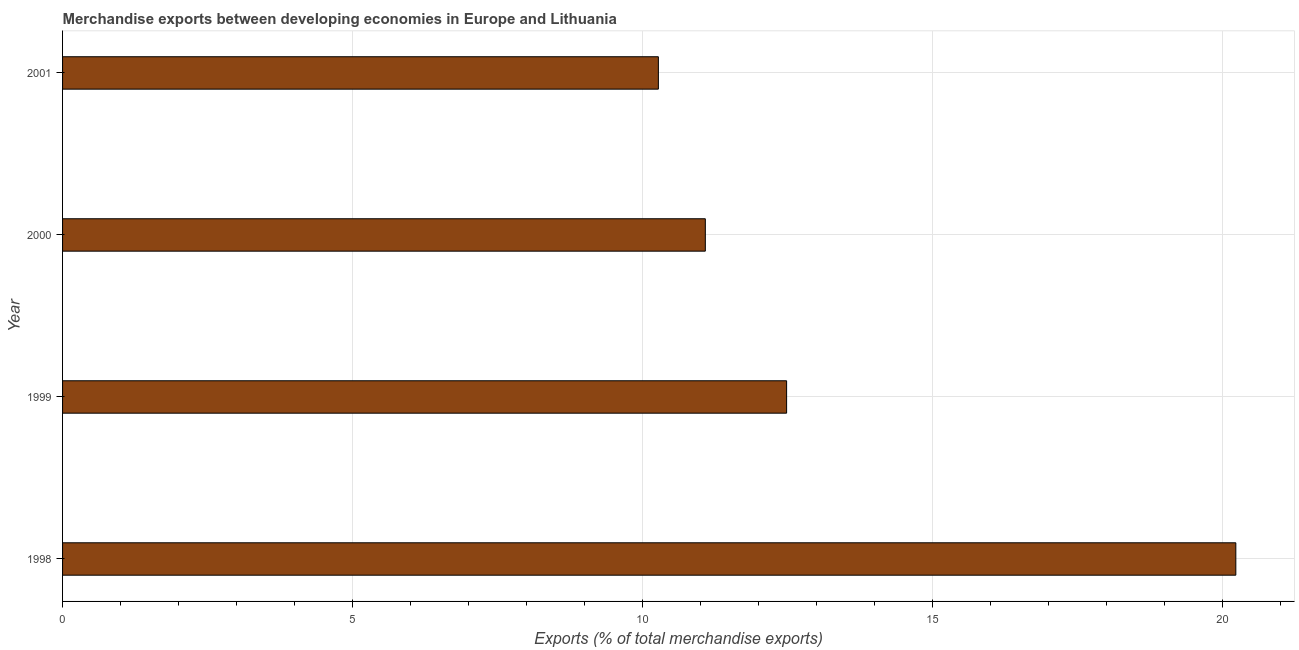Does the graph contain any zero values?
Your response must be concise. No. What is the title of the graph?
Ensure brevity in your answer.  Merchandise exports between developing economies in Europe and Lithuania. What is the label or title of the X-axis?
Give a very brief answer. Exports (% of total merchandise exports). What is the merchandise exports in 1999?
Offer a terse response. 12.49. Across all years, what is the maximum merchandise exports?
Provide a short and direct response. 20.23. Across all years, what is the minimum merchandise exports?
Your answer should be very brief. 10.28. In which year was the merchandise exports maximum?
Your response must be concise. 1998. In which year was the merchandise exports minimum?
Your answer should be very brief. 2001. What is the sum of the merchandise exports?
Give a very brief answer. 54.08. What is the difference between the merchandise exports in 1998 and 1999?
Provide a short and direct response. 7.75. What is the average merchandise exports per year?
Your answer should be very brief. 13.52. What is the median merchandise exports?
Provide a succinct answer. 11.79. Do a majority of the years between 1999 and 1998 (inclusive) have merchandise exports greater than 20 %?
Provide a succinct answer. No. What is the ratio of the merchandise exports in 1999 to that in 2001?
Offer a terse response. 1.22. Is the merchandise exports in 1998 less than that in 1999?
Your answer should be compact. No. What is the difference between the highest and the second highest merchandise exports?
Your answer should be very brief. 7.75. What is the difference between the highest and the lowest merchandise exports?
Give a very brief answer. 9.96. In how many years, is the merchandise exports greater than the average merchandise exports taken over all years?
Offer a very short reply. 1. Are all the bars in the graph horizontal?
Keep it short and to the point. Yes. What is the difference between two consecutive major ticks on the X-axis?
Your answer should be very brief. 5. What is the Exports (% of total merchandise exports) of 1998?
Make the answer very short. 20.23. What is the Exports (% of total merchandise exports) in 1999?
Offer a terse response. 12.49. What is the Exports (% of total merchandise exports) of 2000?
Provide a short and direct response. 11.09. What is the Exports (% of total merchandise exports) in 2001?
Your answer should be very brief. 10.28. What is the difference between the Exports (% of total merchandise exports) in 1998 and 1999?
Ensure brevity in your answer.  7.75. What is the difference between the Exports (% of total merchandise exports) in 1998 and 2000?
Provide a short and direct response. 9.15. What is the difference between the Exports (% of total merchandise exports) in 1998 and 2001?
Keep it short and to the point. 9.96. What is the difference between the Exports (% of total merchandise exports) in 1999 and 2000?
Make the answer very short. 1.4. What is the difference between the Exports (% of total merchandise exports) in 1999 and 2001?
Offer a terse response. 2.21. What is the difference between the Exports (% of total merchandise exports) in 2000 and 2001?
Offer a terse response. 0.81. What is the ratio of the Exports (% of total merchandise exports) in 1998 to that in 1999?
Offer a terse response. 1.62. What is the ratio of the Exports (% of total merchandise exports) in 1998 to that in 2000?
Provide a succinct answer. 1.82. What is the ratio of the Exports (% of total merchandise exports) in 1998 to that in 2001?
Your answer should be compact. 1.97. What is the ratio of the Exports (% of total merchandise exports) in 1999 to that in 2000?
Your response must be concise. 1.13. What is the ratio of the Exports (% of total merchandise exports) in 1999 to that in 2001?
Your answer should be compact. 1.22. What is the ratio of the Exports (% of total merchandise exports) in 2000 to that in 2001?
Ensure brevity in your answer.  1.08. 